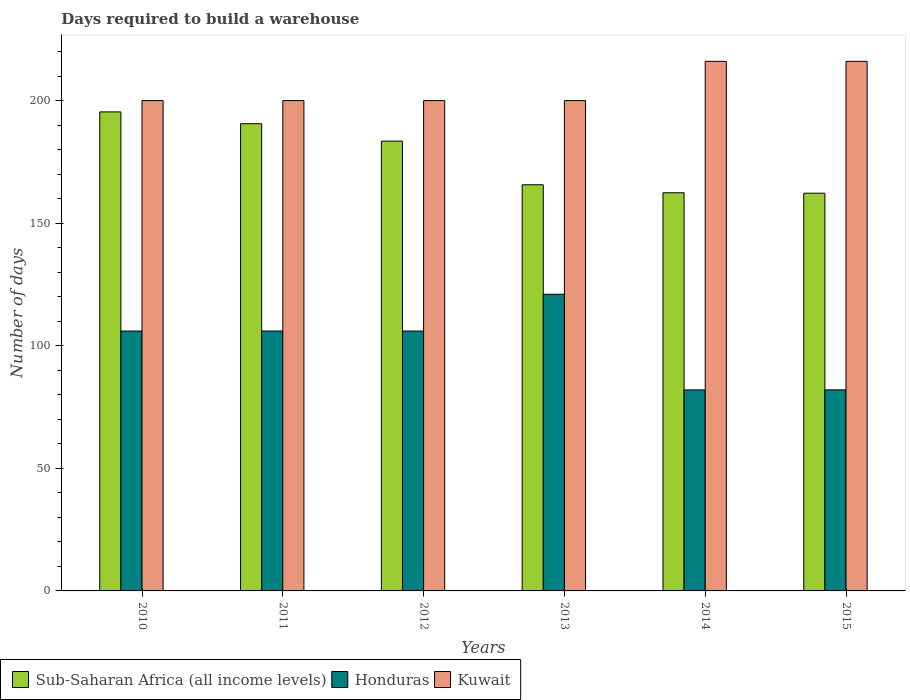How many groups of bars are there?
Your answer should be compact. 6. Are the number of bars per tick equal to the number of legend labels?
Your answer should be compact. Yes. How many bars are there on the 4th tick from the left?
Offer a very short reply. 3. How many bars are there on the 6th tick from the right?
Keep it short and to the point. 3. What is the days required to build a warehouse in in Sub-Saharan Africa (all income levels) in 2012?
Give a very brief answer. 183.47. Across all years, what is the maximum days required to build a warehouse in in Honduras?
Give a very brief answer. 121. Across all years, what is the minimum days required to build a warehouse in in Honduras?
Provide a short and direct response. 82. In which year was the days required to build a warehouse in in Kuwait maximum?
Your answer should be very brief. 2014. What is the total days required to build a warehouse in in Kuwait in the graph?
Provide a short and direct response. 1232. What is the difference between the days required to build a warehouse in in Sub-Saharan Africa (all income levels) in 2010 and the days required to build a warehouse in in Honduras in 2014?
Your answer should be very brief. 113.39. What is the average days required to build a warehouse in in Honduras per year?
Your answer should be very brief. 100.5. In the year 2010, what is the difference between the days required to build a warehouse in in Sub-Saharan Africa (all income levels) and days required to build a warehouse in in Kuwait?
Give a very brief answer. -4.61. In how many years, is the days required to build a warehouse in in Honduras greater than 100 days?
Ensure brevity in your answer.  4. What is the ratio of the days required to build a warehouse in in Honduras in 2011 to that in 2014?
Offer a terse response. 1.29. Is the difference between the days required to build a warehouse in in Sub-Saharan Africa (all income levels) in 2013 and 2015 greater than the difference between the days required to build a warehouse in in Kuwait in 2013 and 2015?
Give a very brief answer. Yes. What is the difference between the highest and the second highest days required to build a warehouse in in Honduras?
Your answer should be very brief. 15. What is the difference between the highest and the lowest days required to build a warehouse in in Sub-Saharan Africa (all income levels)?
Make the answer very short. 33.16. In how many years, is the days required to build a warehouse in in Kuwait greater than the average days required to build a warehouse in in Kuwait taken over all years?
Offer a terse response. 2. What does the 1st bar from the left in 2013 represents?
Offer a very short reply. Sub-Saharan Africa (all income levels). What does the 1st bar from the right in 2013 represents?
Offer a very short reply. Kuwait. Is it the case that in every year, the sum of the days required to build a warehouse in in Kuwait and days required to build a warehouse in in Sub-Saharan Africa (all income levels) is greater than the days required to build a warehouse in in Honduras?
Offer a very short reply. Yes. How many years are there in the graph?
Make the answer very short. 6. What is the difference between two consecutive major ticks on the Y-axis?
Your answer should be compact. 50. Does the graph contain grids?
Your answer should be very brief. No. How many legend labels are there?
Ensure brevity in your answer.  3. What is the title of the graph?
Make the answer very short. Days required to build a warehouse. What is the label or title of the Y-axis?
Make the answer very short. Number of days. What is the Number of days in Sub-Saharan Africa (all income levels) in 2010?
Give a very brief answer. 195.39. What is the Number of days in Honduras in 2010?
Ensure brevity in your answer.  106. What is the Number of days in Kuwait in 2010?
Make the answer very short. 200. What is the Number of days of Sub-Saharan Africa (all income levels) in 2011?
Offer a very short reply. 190.57. What is the Number of days of Honduras in 2011?
Provide a short and direct response. 106. What is the Number of days of Sub-Saharan Africa (all income levels) in 2012?
Keep it short and to the point. 183.47. What is the Number of days of Honduras in 2012?
Ensure brevity in your answer.  106. What is the Number of days of Sub-Saharan Africa (all income levels) in 2013?
Offer a very short reply. 165.66. What is the Number of days of Honduras in 2013?
Give a very brief answer. 121. What is the Number of days of Sub-Saharan Africa (all income levels) in 2014?
Make the answer very short. 162.4. What is the Number of days of Kuwait in 2014?
Make the answer very short. 216. What is the Number of days in Sub-Saharan Africa (all income levels) in 2015?
Your response must be concise. 162.22. What is the Number of days of Kuwait in 2015?
Your response must be concise. 216. Across all years, what is the maximum Number of days of Sub-Saharan Africa (all income levels)?
Offer a very short reply. 195.39. Across all years, what is the maximum Number of days in Honduras?
Your answer should be compact. 121. Across all years, what is the maximum Number of days in Kuwait?
Offer a very short reply. 216. Across all years, what is the minimum Number of days in Sub-Saharan Africa (all income levels)?
Give a very brief answer. 162.22. Across all years, what is the minimum Number of days of Honduras?
Make the answer very short. 82. Across all years, what is the minimum Number of days of Kuwait?
Your answer should be very brief. 200. What is the total Number of days in Sub-Saharan Africa (all income levels) in the graph?
Provide a succinct answer. 1059.7. What is the total Number of days in Honduras in the graph?
Your answer should be compact. 603. What is the total Number of days of Kuwait in the graph?
Offer a terse response. 1232. What is the difference between the Number of days of Sub-Saharan Africa (all income levels) in 2010 and that in 2011?
Your response must be concise. 4.82. What is the difference between the Number of days in Sub-Saharan Africa (all income levels) in 2010 and that in 2012?
Ensure brevity in your answer.  11.92. What is the difference between the Number of days of Kuwait in 2010 and that in 2012?
Provide a succinct answer. 0. What is the difference between the Number of days in Sub-Saharan Africa (all income levels) in 2010 and that in 2013?
Keep it short and to the point. 29.73. What is the difference between the Number of days of Honduras in 2010 and that in 2013?
Your answer should be very brief. -15. What is the difference between the Number of days of Sub-Saharan Africa (all income levels) in 2010 and that in 2014?
Give a very brief answer. 32.99. What is the difference between the Number of days in Kuwait in 2010 and that in 2014?
Offer a very short reply. -16. What is the difference between the Number of days in Sub-Saharan Africa (all income levels) in 2010 and that in 2015?
Keep it short and to the point. 33.16. What is the difference between the Number of days of Sub-Saharan Africa (all income levels) in 2011 and that in 2012?
Provide a succinct answer. 7.1. What is the difference between the Number of days in Sub-Saharan Africa (all income levels) in 2011 and that in 2013?
Give a very brief answer. 24.91. What is the difference between the Number of days of Honduras in 2011 and that in 2013?
Your answer should be very brief. -15. What is the difference between the Number of days of Sub-Saharan Africa (all income levels) in 2011 and that in 2014?
Offer a very short reply. 28.17. What is the difference between the Number of days in Kuwait in 2011 and that in 2014?
Your answer should be compact. -16. What is the difference between the Number of days of Sub-Saharan Africa (all income levels) in 2011 and that in 2015?
Provide a succinct answer. 28.34. What is the difference between the Number of days in Honduras in 2011 and that in 2015?
Give a very brief answer. 24. What is the difference between the Number of days in Sub-Saharan Africa (all income levels) in 2012 and that in 2013?
Make the answer very short. 17.81. What is the difference between the Number of days in Honduras in 2012 and that in 2013?
Your answer should be compact. -15. What is the difference between the Number of days of Kuwait in 2012 and that in 2013?
Make the answer very short. 0. What is the difference between the Number of days of Sub-Saharan Africa (all income levels) in 2012 and that in 2014?
Keep it short and to the point. 21.07. What is the difference between the Number of days in Honduras in 2012 and that in 2014?
Offer a very short reply. 24. What is the difference between the Number of days of Sub-Saharan Africa (all income levels) in 2012 and that in 2015?
Provide a succinct answer. 21.24. What is the difference between the Number of days in Sub-Saharan Africa (all income levels) in 2013 and that in 2014?
Ensure brevity in your answer.  3.26. What is the difference between the Number of days of Kuwait in 2013 and that in 2014?
Keep it short and to the point. -16. What is the difference between the Number of days of Sub-Saharan Africa (all income levels) in 2013 and that in 2015?
Your answer should be compact. 3.43. What is the difference between the Number of days in Kuwait in 2013 and that in 2015?
Keep it short and to the point. -16. What is the difference between the Number of days in Sub-Saharan Africa (all income levels) in 2014 and that in 2015?
Ensure brevity in your answer.  0.17. What is the difference between the Number of days of Kuwait in 2014 and that in 2015?
Your answer should be very brief. 0. What is the difference between the Number of days of Sub-Saharan Africa (all income levels) in 2010 and the Number of days of Honduras in 2011?
Your answer should be very brief. 89.39. What is the difference between the Number of days of Sub-Saharan Africa (all income levels) in 2010 and the Number of days of Kuwait in 2011?
Your answer should be very brief. -4.61. What is the difference between the Number of days in Honduras in 2010 and the Number of days in Kuwait in 2011?
Provide a succinct answer. -94. What is the difference between the Number of days of Sub-Saharan Africa (all income levels) in 2010 and the Number of days of Honduras in 2012?
Keep it short and to the point. 89.39. What is the difference between the Number of days in Sub-Saharan Africa (all income levels) in 2010 and the Number of days in Kuwait in 2012?
Provide a succinct answer. -4.61. What is the difference between the Number of days in Honduras in 2010 and the Number of days in Kuwait in 2012?
Your response must be concise. -94. What is the difference between the Number of days in Sub-Saharan Africa (all income levels) in 2010 and the Number of days in Honduras in 2013?
Your answer should be compact. 74.39. What is the difference between the Number of days in Sub-Saharan Africa (all income levels) in 2010 and the Number of days in Kuwait in 2013?
Keep it short and to the point. -4.61. What is the difference between the Number of days in Honduras in 2010 and the Number of days in Kuwait in 2013?
Offer a very short reply. -94. What is the difference between the Number of days of Sub-Saharan Africa (all income levels) in 2010 and the Number of days of Honduras in 2014?
Your answer should be compact. 113.39. What is the difference between the Number of days in Sub-Saharan Africa (all income levels) in 2010 and the Number of days in Kuwait in 2014?
Your response must be concise. -20.61. What is the difference between the Number of days of Honduras in 2010 and the Number of days of Kuwait in 2014?
Offer a terse response. -110. What is the difference between the Number of days in Sub-Saharan Africa (all income levels) in 2010 and the Number of days in Honduras in 2015?
Your answer should be compact. 113.39. What is the difference between the Number of days of Sub-Saharan Africa (all income levels) in 2010 and the Number of days of Kuwait in 2015?
Give a very brief answer. -20.61. What is the difference between the Number of days in Honduras in 2010 and the Number of days in Kuwait in 2015?
Your answer should be very brief. -110. What is the difference between the Number of days in Sub-Saharan Africa (all income levels) in 2011 and the Number of days in Honduras in 2012?
Ensure brevity in your answer.  84.57. What is the difference between the Number of days in Sub-Saharan Africa (all income levels) in 2011 and the Number of days in Kuwait in 2012?
Make the answer very short. -9.43. What is the difference between the Number of days of Honduras in 2011 and the Number of days of Kuwait in 2012?
Give a very brief answer. -94. What is the difference between the Number of days in Sub-Saharan Africa (all income levels) in 2011 and the Number of days in Honduras in 2013?
Provide a succinct answer. 69.57. What is the difference between the Number of days of Sub-Saharan Africa (all income levels) in 2011 and the Number of days of Kuwait in 2013?
Offer a terse response. -9.43. What is the difference between the Number of days of Honduras in 2011 and the Number of days of Kuwait in 2013?
Offer a terse response. -94. What is the difference between the Number of days in Sub-Saharan Africa (all income levels) in 2011 and the Number of days in Honduras in 2014?
Your answer should be very brief. 108.57. What is the difference between the Number of days in Sub-Saharan Africa (all income levels) in 2011 and the Number of days in Kuwait in 2014?
Offer a terse response. -25.43. What is the difference between the Number of days of Honduras in 2011 and the Number of days of Kuwait in 2014?
Your answer should be very brief. -110. What is the difference between the Number of days of Sub-Saharan Africa (all income levels) in 2011 and the Number of days of Honduras in 2015?
Give a very brief answer. 108.57. What is the difference between the Number of days of Sub-Saharan Africa (all income levels) in 2011 and the Number of days of Kuwait in 2015?
Keep it short and to the point. -25.43. What is the difference between the Number of days of Honduras in 2011 and the Number of days of Kuwait in 2015?
Ensure brevity in your answer.  -110. What is the difference between the Number of days in Sub-Saharan Africa (all income levels) in 2012 and the Number of days in Honduras in 2013?
Your response must be concise. 62.47. What is the difference between the Number of days in Sub-Saharan Africa (all income levels) in 2012 and the Number of days in Kuwait in 2013?
Provide a succinct answer. -16.53. What is the difference between the Number of days of Honduras in 2012 and the Number of days of Kuwait in 2013?
Offer a terse response. -94. What is the difference between the Number of days in Sub-Saharan Africa (all income levels) in 2012 and the Number of days in Honduras in 2014?
Your answer should be compact. 101.47. What is the difference between the Number of days in Sub-Saharan Africa (all income levels) in 2012 and the Number of days in Kuwait in 2014?
Your answer should be compact. -32.53. What is the difference between the Number of days in Honduras in 2012 and the Number of days in Kuwait in 2014?
Ensure brevity in your answer.  -110. What is the difference between the Number of days in Sub-Saharan Africa (all income levels) in 2012 and the Number of days in Honduras in 2015?
Keep it short and to the point. 101.47. What is the difference between the Number of days of Sub-Saharan Africa (all income levels) in 2012 and the Number of days of Kuwait in 2015?
Make the answer very short. -32.53. What is the difference between the Number of days in Honduras in 2012 and the Number of days in Kuwait in 2015?
Make the answer very short. -110. What is the difference between the Number of days in Sub-Saharan Africa (all income levels) in 2013 and the Number of days in Honduras in 2014?
Offer a terse response. 83.66. What is the difference between the Number of days in Sub-Saharan Africa (all income levels) in 2013 and the Number of days in Kuwait in 2014?
Your answer should be compact. -50.34. What is the difference between the Number of days in Honduras in 2013 and the Number of days in Kuwait in 2014?
Offer a very short reply. -95. What is the difference between the Number of days of Sub-Saharan Africa (all income levels) in 2013 and the Number of days of Honduras in 2015?
Keep it short and to the point. 83.66. What is the difference between the Number of days of Sub-Saharan Africa (all income levels) in 2013 and the Number of days of Kuwait in 2015?
Your response must be concise. -50.34. What is the difference between the Number of days of Honduras in 2013 and the Number of days of Kuwait in 2015?
Provide a short and direct response. -95. What is the difference between the Number of days in Sub-Saharan Africa (all income levels) in 2014 and the Number of days in Honduras in 2015?
Offer a terse response. 80.4. What is the difference between the Number of days in Sub-Saharan Africa (all income levels) in 2014 and the Number of days in Kuwait in 2015?
Your answer should be very brief. -53.6. What is the difference between the Number of days of Honduras in 2014 and the Number of days of Kuwait in 2015?
Your answer should be compact. -134. What is the average Number of days in Sub-Saharan Africa (all income levels) per year?
Your answer should be very brief. 176.62. What is the average Number of days in Honduras per year?
Give a very brief answer. 100.5. What is the average Number of days in Kuwait per year?
Provide a short and direct response. 205.33. In the year 2010, what is the difference between the Number of days in Sub-Saharan Africa (all income levels) and Number of days in Honduras?
Ensure brevity in your answer.  89.39. In the year 2010, what is the difference between the Number of days in Sub-Saharan Africa (all income levels) and Number of days in Kuwait?
Your response must be concise. -4.61. In the year 2010, what is the difference between the Number of days in Honduras and Number of days in Kuwait?
Offer a terse response. -94. In the year 2011, what is the difference between the Number of days in Sub-Saharan Africa (all income levels) and Number of days in Honduras?
Keep it short and to the point. 84.57. In the year 2011, what is the difference between the Number of days in Sub-Saharan Africa (all income levels) and Number of days in Kuwait?
Offer a terse response. -9.43. In the year 2011, what is the difference between the Number of days of Honduras and Number of days of Kuwait?
Provide a succinct answer. -94. In the year 2012, what is the difference between the Number of days in Sub-Saharan Africa (all income levels) and Number of days in Honduras?
Your response must be concise. 77.47. In the year 2012, what is the difference between the Number of days in Sub-Saharan Africa (all income levels) and Number of days in Kuwait?
Offer a very short reply. -16.53. In the year 2012, what is the difference between the Number of days in Honduras and Number of days in Kuwait?
Your response must be concise. -94. In the year 2013, what is the difference between the Number of days of Sub-Saharan Africa (all income levels) and Number of days of Honduras?
Offer a terse response. 44.66. In the year 2013, what is the difference between the Number of days of Sub-Saharan Africa (all income levels) and Number of days of Kuwait?
Keep it short and to the point. -34.34. In the year 2013, what is the difference between the Number of days in Honduras and Number of days in Kuwait?
Your answer should be compact. -79. In the year 2014, what is the difference between the Number of days in Sub-Saharan Africa (all income levels) and Number of days in Honduras?
Provide a short and direct response. 80.4. In the year 2014, what is the difference between the Number of days of Sub-Saharan Africa (all income levels) and Number of days of Kuwait?
Provide a succinct answer. -53.6. In the year 2014, what is the difference between the Number of days of Honduras and Number of days of Kuwait?
Provide a succinct answer. -134. In the year 2015, what is the difference between the Number of days of Sub-Saharan Africa (all income levels) and Number of days of Honduras?
Offer a very short reply. 80.22. In the year 2015, what is the difference between the Number of days in Sub-Saharan Africa (all income levels) and Number of days in Kuwait?
Keep it short and to the point. -53.78. In the year 2015, what is the difference between the Number of days in Honduras and Number of days in Kuwait?
Keep it short and to the point. -134. What is the ratio of the Number of days in Sub-Saharan Africa (all income levels) in 2010 to that in 2011?
Your answer should be very brief. 1.03. What is the ratio of the Number of days of Honduras in 2010 to that in 2011?
Provide a succinct answer. 1. What is the ratio of the Number of days in Kuwait in 2010 to that in 2011?
Your response must be concise. 1. What is the ratio of the Number of days of Sub-Saharan Africa (all income levels) in 2010 to that in 2012?
Ensure brevity in your answer.  1.06. What is the ratio of the Number of days in Sub-Saharan Africa (all income levels) in 2010 to that in 2013?
Offer a terse response. 1.18. What is the ratio of the Number of days of Honduras in 2010 to that in 2013?
Ensure brevity in your answer.  0.88. What is the ratio of the Number of days of Kuwait in 2010 to that in 2013?
Your response must be concise. 1. What is the ratio of the Number of days of Sub-Saharan Africa (all income levels) in 2010 to that in 2014?
Provide a short and direct response. 1.2. What is the ratio of the Number of days in Honduras in 2010 to that in 2014?
Make the answer very short. 1.29. What is the ratio of the Number of days of Kuwait in 2010 to that in 2014?
Ensure brevity in your answer.  0.93. What is the ratio of the Number of days in Sub-Saharan Africa (all income levels) in 2010 to that in 2015?
Make the answer very short. 1.2. What is the ratio of the Number of days in Honduras in 2010 to that in 2015?
Give a very brief answer. 1.29. What is the ratio of the Number of days in Kuwait in 2010 to that in 2015?
Offer a terse response. 0.93. What is the ratio of the Number of days of Sub-Saharan Africa (all income levels) in 2011 to that in 2012?
Make the answer very short. 1.04. What is the ratio of the Number of days of Honduras in 2011 to that in 2012?
Provide a succinct answer. 1. What is the ratio of the Number of days of Sub-Saharan Africa (all income levels) in 2011 to that in 2013?
Ensure brevity in your answer.  1.15. What is the ratio of the Number of days in Honduras in 2011 to that in 2013?
Provide a short and direct response. 0.88. What is the ratio of the Number of days in Sub-Saharan Africa (all income levels) in 2011 to that in 2014?
Ensure brevity in your answer.  1.17. What is the ratio of the Number of days of Honduras in 2011 to that in 2014?
Your response must be concise. 1.29. What is the ratio of the Number of days of Kuwait in 2011 to that in 2014?
Provide a succinct answer. 0.93. What is the ratio of the Number of days in Sub-Saharan Africa (all income levels) in 2011 to that in 2015?
Your answer should be compact. 1.17. What is the ratio of the Number of days of Honduras in 2011 to that in 2015?
Your answer should be very brief. 1.29. What is the ratio of the Number of days in Kuwait in 2011 to that in 2015?
Provide a short and direct response. 0.93. What is the ratio of the Number of days of Sub-Saharan Africa (all income levels) in 2012 to that in 2013?
Ensure brevity in your answer.  1.11. What is the ratio of the Number of days of Honduras in 2012 to that in 2013?
Keep it short and to the point. 0.88. What is the ratio of the Number of days of Kuwait in 2012 to that in 2013?
Give a very brief answer. 1. What is the ratio of the Number of days of Sub-Saharan Africa (all income levels) in 2012 to that in 2014?
Provide a succinct answer. 1.13. What is the ratio of the Number of days in Honduras in 2012 to that in 2014?
Offer a very short reply. 1.29. What is the ratio of the Number of days of Kuwait in 2012 to that in 2014?
Offer a terse response. 0.93. What is the ratio of the Number of days of Sub-Saharan Africa (all income levels) in 2012 to that in 2015?
Offer a terse response. 1.13. What is the ratio of the Number of days in Honduras in 2012 to that in 2015?
Keep it short and to the point. 1.29. What is the ratio of the Number of days in Kuwait in 2012 to that in 2015?
Ensure brevity in your answer.  0.93. What is the ratio of the Number of days in Sub-Saharan Africa (all income levels) in 2013 to that in 2014?
Give a very brief answer. 1.02. What is the ratio of the Number of days in Honduras in 2013 to that in 2014?
Your answer should be very brief. 1.48. What is the ratio of the Number of days in Kuwait in 2013 to that in 2014?
Offer a terse response. 0.93. What is the ratio of the Number of days in Sub-Saharan Africa (all income levels) in 2013 to that in 2015?
Provide a succinct answer. 1.02. What is the ratio of the Number of days in Honduras in 2013 to that in 2015?
Your answer should be very brief. 1.48. What is the ratio of the Number of days in Kuwait in 2013 to that in 2015?
Provide a short and direct response. 0.93. What is the difference between the highest and the second highest Number of days in Sub-Saharan Africa (all income levels)?
Give a very brief answer. 4.82. What is the difference between the highest and the second highest Number of days in Honduras?
Your answer should be compact. 15. What is the difference between the highest and the lowest Number of days of Sub-Saharan Africa (all income levels)?
Your response must be concise. 33.16. What is the difference between the highest and the lowest Number of days of Kuwait?
Your answer should be compact. 16. 